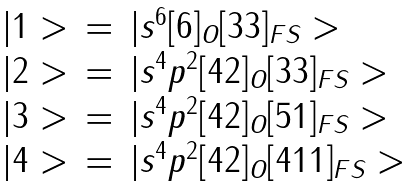<formula> <loc_0><loc_0><loc_500><loc_500>\begin{array} { c l l } { | 1 > } & { = } & { { | s ^ { 6 } [ 6 ] _ { O } [ 3 3 ] _ { F S } > } } \\ { | 2 > } & { = } & { { | s ^ { 4 } p ^ { 2 } [ 4 2 ] _ { O } [ 3 3 ] _ { F S } > } } \\ { | 3 > } & { = } & { { | s ^ { 4 } p ^ { 2 } [ 4 2 ] _ { O } [ 5 1 ] _ { F S } > } } \\ { | 4 > } & { = } & { { | s ^ { 4 } p ^ { 2 } [ 4 2 ] _ { O } [ 4 1 1 ] _ { F S } > } } \end{array}</formula> 